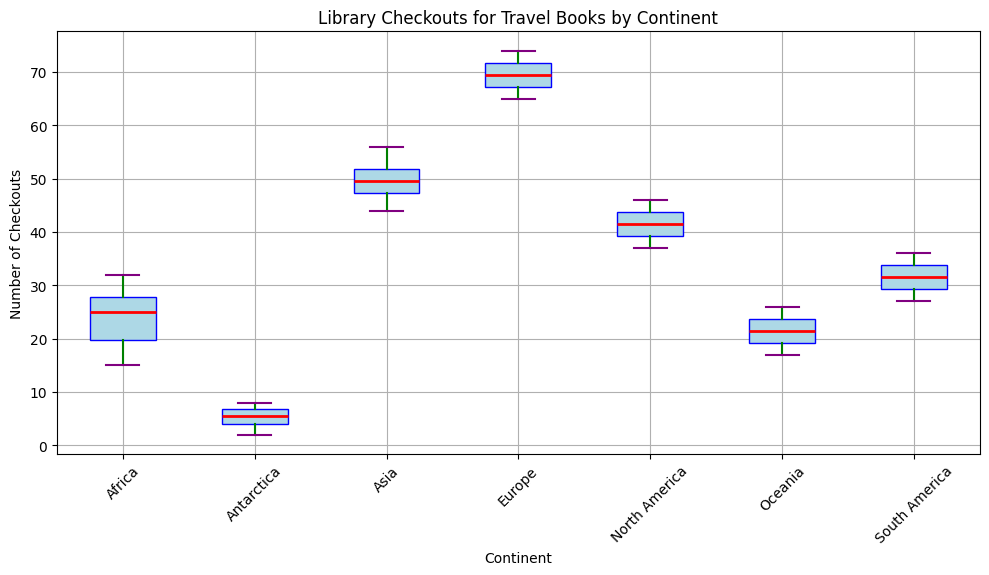What is the median number of checkouts for travel books for Asia? Look at the red line inside the blue box for Asia; this line represents the median value.
Answer: 49 Which continent has the lowest median number of checkouts? Compare the red lines inside the blue boxes for all continents; the lowest line represents the lowest median.
Answer: Antarctica What is the range of the number of checkouts for Africa? The range is the difference between the maximum and minimum values represented by the top and bottom "whiskers" of the box plot for Africa.
Answer: 17 (32 - 15) Which continent has the highest variance in checkouts? Look at the length of the blue boxes (interquartile range) and the length of whiskers (spread of the data); the continent with the widest box and whiskers has the highest variance.
Answer: Europe How many continents have a median number of checkouts greater than 40? Look at the red lines inside the blue boxes and count how many lines are above the 40 mark on the y-axis.
Answer: 3 (Asia, Europe, North America) What is the interquartile range (IQR) of checkouts for North America? Calculate the difference between the top and bottom of the blue box for North America; the top represents the 75th percentile, and the bottom represents the 25th percentile.
Answer: 6 (45 - 39) Compare the median number of checkouts for Europe and Asia. Which one is higher? Compare the red lines inside the blue boxes for Europe and Asia; the higher line indicates the higher median.
Answer: Europe Which continent has the most outliers in its data? Identify the continent with the most orange circles (outliers) outside the whiskers.
Answer: Africa What is the median number of checkouts for Antarctica? Look at the red line inside the blue box for Antarctica; this line represents the median value.
Answer: 5 Which continent has a similar median number of checkouts to South America? Compare the red lines inside the blue boxes; look for another red line close to the line for South America.
Answer: North America 